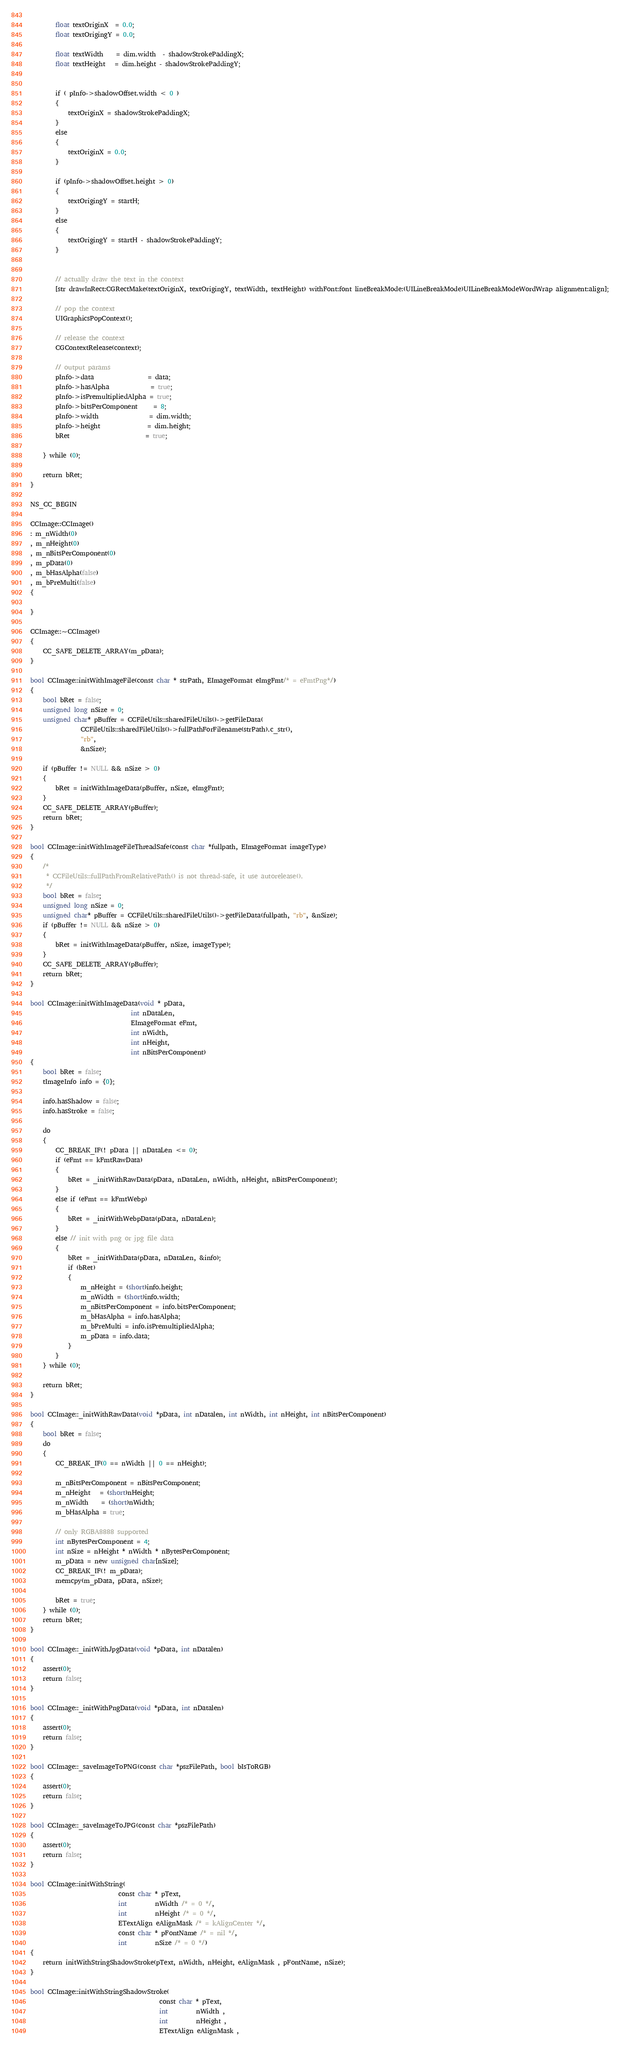Convert code to text. <code><loc_0><loc_0><loc_500><loc_500><_ObjectiveC_>        
        float textOriginX  = 0.0;
        float textOrigingY = 0.0;
        
        float textWidth    = dim.width  - shadowStrokePaddingX;
        float textHeight   = dim.height - shadowStrokePaddingY;
        
        
        if ( pInfo->shadowOffset.width < 0 )
        {
            textOriginX = shadowStrokePaddingX;
        }
        else
        {
            textOriginX = 0.0;
        }
        
        if (pInfo->shadowOffset.height > 0)
        {
            textOrigingY = startH;
        }
        else
        {
            textOrigingY = startH - shadowStrokePaddingY;
        }
        
        
        // actually draw the text in the context
        [str drawInRect:CGRectMake(textOriginX, textOrigingY, textWidth, textHeight) withFont:font lineBreakMode:(UILineBreakMode)UILineBreakModeWordWrap alignment:align];
        
        // pop the context
        UIGraphicsPopContext();
        
        // release the context
        CGContextRelease(context);
               
        // output params
        pInfo->data                 = data;
        pInfo->hasAlpha             = true;
        pInfo->isPremultipliedAlpha = true;
        pInfo->bitsPerComponent     = 8;
        pInfo->width                = dim.width;
        pInfo->height               = dim.height;
        bRet                        = true;
        
    } while (0);

    return bRet;
}

NS_CC_BEGIN

CCImage::CCImage()
: m_nWidth(0)
, m_nHeight(0)
, m_nBitsPerComponent(0)
, m_pData(0)
, m_bHasAlpha(false)
, m_bPreMulti(false)
{
    
}

CCImage::~CCImage()
{
    CC_SAFE_DELETE_ARRAY(m_pData);
}

bool CCImage::initWithImageFile(const char * strPath, EImageFormat eImgFmt/* = eFmtPng*/)
{
	bool bRet = false;
    unsigned long nSize = 0;
    unsigned char* pBuffer = CCFileUtils::sharedFileUtils()->getFileData(
				CCFileUtils::sharedFileUtils()->fullPathForFilename(strPath).c_str(),
				"rb",
				&nSize);
				
    if (pBuffer != NULL && nSize > 0)
    {
        bRet = initWithImageData(pBuffer, nSize, eImgFmt);
    }
    CC_SAFE_DELETE_ARRAY(pBuffer);
    return bRet;
}

bool CCImage::initWithImageFileThreadSafe(const char *fullpath, EImageFormat imageType)
{
    /*
     * CCFileUtils::fullPathFromRelativePath() is not thread-safe, it use autorelease().
     */
    bool bRet = false;
    unsigned long nSize = 0;
    unsigned char* pBuffer = CCFileUtils::sharedFileUtils()->getFileData(fullpath, "rb", &nSize);
    if (pBuffer != NULL && nSize > 0)
    {
        bRet = initWithImageData(pBuffer, nSize, imageType);
    }
    CC_SAFE_DELETE_ARRAY(pBuffer);
    return bRet;
}

bool CCImage::initWithImageData(void * pData, 
                                int nDataLen, 
                                EImageFormat eFmt,
                                int nWidth,
                                int nHeight,
                                int nBitsPerComponent)
{
    bool bRet = false;
    tImageInfo info = {0};
    
    info.hasShadow = false;
    info.hasStroke = false;
    
    do 
    {
        CC_BREAK_IF(! pData || nDataLen <= 0);
        if (eFmt == kFmtRawData)
        {
            bRet = _initWithRawData(pData, nDataLen, nWidth, nHeight, nBitsPerComponent);
        }
        else if (eFmt == kFmtWebp)
        {
            bRet = _initWithWebpData(pData, nDataLen);
        }
        else // init with png or jpg file data
        {
            bRet = _initWithData(pData, nDataLen, &info);
            if (bRet)
            {
                m_nHeight = (short)info.height;
                m_nWidth = (short)info.width;
                m_nBitsPerComponent = info.bitsPerComponent;
                m_bHasAlpha = info.hasAlpha;
                m_bPreMulti = info.isPremultipliedAlpha;
                m_pData = info.data;
            }
        }
    } while (0);
    
    return bRet;
}

bool CCImage::_initWithRawData(void *pData, int nDatalen, int nWidth, int nHeight, int nBitsPerComponent)
{
    bool bRet = false;
    do 
    {
        CC_BREAK_IF(0 == nWidth || 0 == nHeight);

        m_nBitsPerComponent = nBitsPerComponent;
        m_nHeight   = (short)nHeight;
        m_nWidth    = (short)nWidth;
        m_bHasAlpha = true;

        // only RGBA8888 supported
        int nBytesPerComponent = 4;
        int nSize = nHeight * nWidth * nBytesPerComponent;
        m_pData = new unsigned char[nSize];
        CC_BREAK_IF(! m_pData);
        memcpy(m_pData, pData, nSize);

        bRet = true;
    } while (0);
    return bRet;
}

bool CCImage::_initWithJpgData(void *pData, int nDatalen)
{
    assert(0);
	return false;
}

bool CCImage::_initWithPngData(void *pData, int nDatalen)
{
    assert(0);
	return false;
}

bool CCImage::_saveImageToPNG(const char *pszFilePath, bool bIsToRGB)
{
    assert(0);
	return false;
}

bool CCImage::_saveImageToJPG(const char *pszFilePath)
{
    assert(0);
	return false;
}

bool CCImage::initWithString(
                            const char * pText,
                            int         nWidth /* = 0 */,
                            int         nHeight /* = 0 */,
                            ETextAlign eAlignMask /* = kAlignCenter */,
                            const char * pFontName /* = nil */,
                            int         nSize /* = 0 */)
{
    return initWithStringShadowStroke(pText, nWidth, nHeight, eAlignMask , pFontName, nSize);
}

bool CCImage::initWithStringShadowStroke(
                                         const char * pText,
                                         int         nWidth ,
                                         int         nHeight ,
                                         ETextAlign eAlignMask ,</code> 